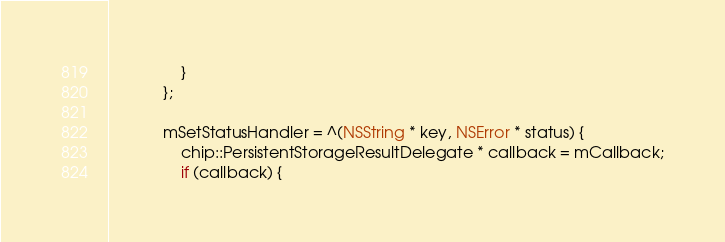<code> <loc_0><loc_0><loc_500><loc_500><_ObjectiveC_>                }
            };

            mSetStatusHandler = ^(NSString * key, NSError * status) {
                chip::PersistentStorageResultDelegate * callback = mCallback;
                if (callback) {</code> 